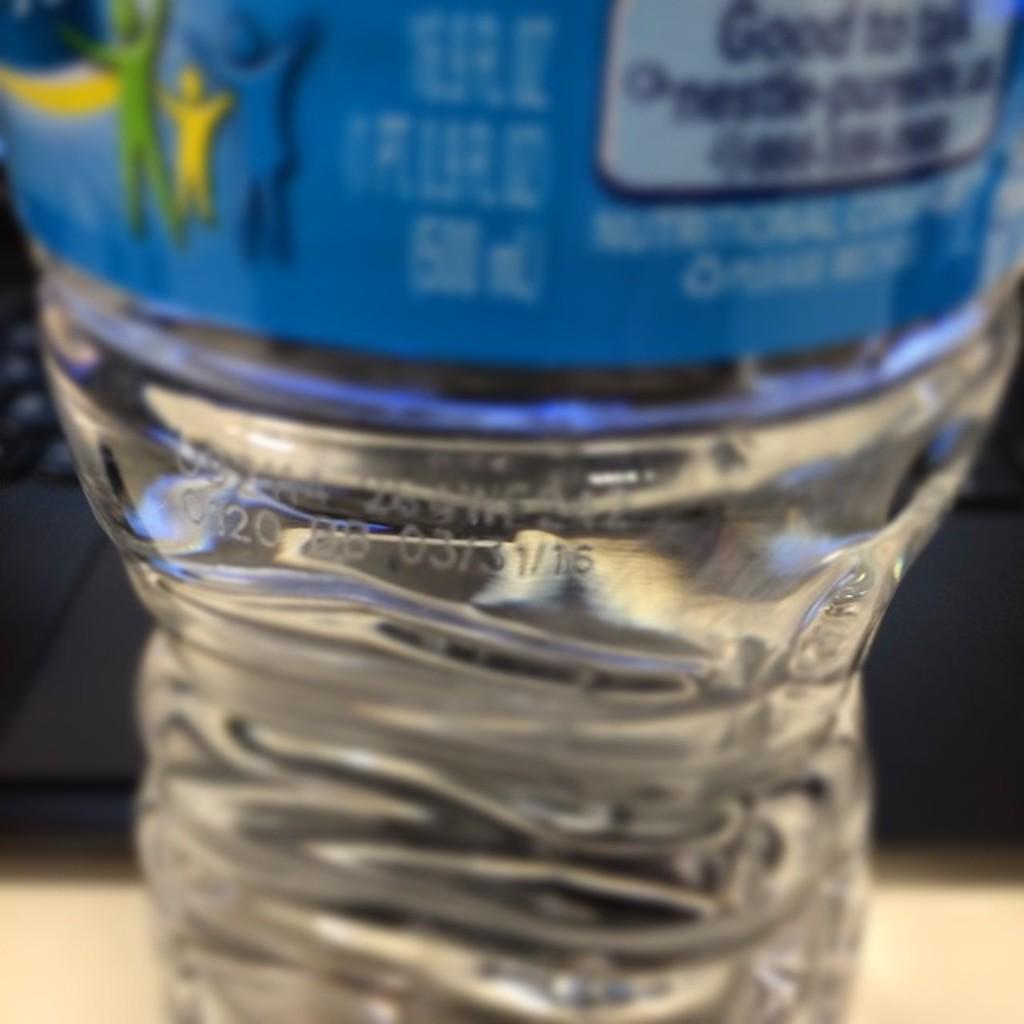How would you summarize this image in a sentence or two? In this image there is a picture of a water bottle with date, manufacturing date with a label kept on a table. 